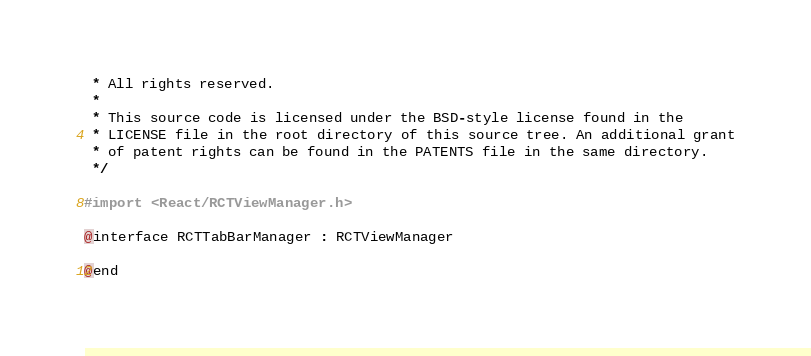Convert code to text. <code><loc_0><loc_0><loc_500><loc_500><_C_> * All rights reserved.
 *
 * This source code is licensed under the BSD-style license found in the
 * LICENSE file in the root directory of this source tree. An additional grant
 * of patent rights can be found in the PATENTS file in the same directory.
 */

#import <React/RCTViewManager.h>

@interface RCTTabBarManager : RCTViewManager

@end
</code> 